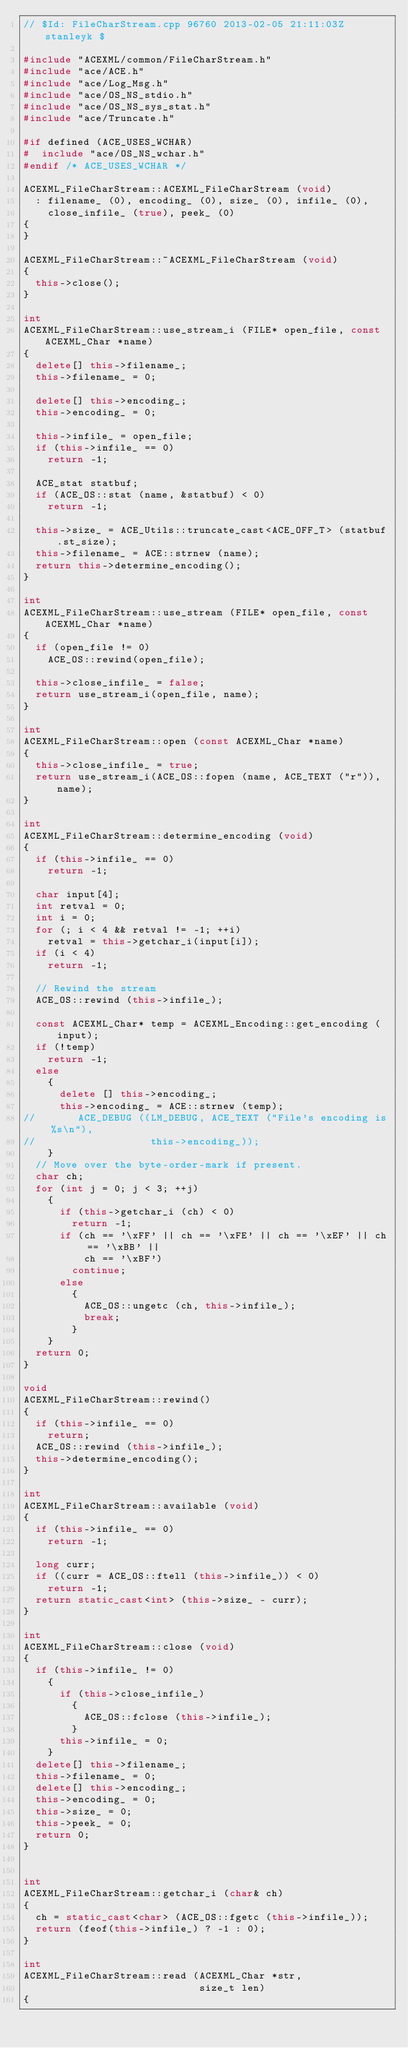Convert code to text. <code><loc_0><loc_0><loc_500><loc_500><_C++_>// $Id: FileCharStream.cpp 96760 2013-02-05 21:11:03Z stanleyk $

#include "ACEXML/common/FileCharStream.h"
#include "ace/ACE.h"
#include "ace/Log_Msg.h"
#include "ace/OS_NS_stdio.h"
#include "ace/OS_NS_sys_stat.h"
#include "ace/Truncate.h"

#if defined (ACE_USES_WCHAR)
#  include "ace/OS_NS_wchar.h"
#endif /* ACE_USES_WCHAR */

ACEXML_FileCharStream::ACEXML_FileCharStream (void)
  : filename_ (0), encoding_ (0), size_ (0), infile_ (0),
    close_infile_ (true), peek_ (0)
{
}

ACEXML_FileCharStream::~ACEXML_FileCharStream (void)
{
  this->close();
}

int
ACEXML_FileCharStream::use_stream_i (FILE* open_file, const ACEXML_Char *name)
{
  delete[] this->filename_;
  this->filename_ = 0;

  delete[] this->encoding_;
  this->encoding_ = 0;

  this->infile_ = open_file;
  if (this->infile_ == 0)
    return -1;

  ACE_stat statbuf;
  if (ACE_OS::stat (name, &statbuf) < 0)
    return -1;

  this->size_ = ACE_Utils::truncate_cast<ACE_OFF_T> (statbuf.st_size);
  this->filename_ = ACE::strnew (name);
  return this->determine_encoding();
}

int
ACEXML_FileCharStream::use_stream (FILE* open_file, const ACEXML_Char *name)
{
  if (open_file != 0)
    ACE_OS::rewind(open_file);

  this->close_infile_ = false;
  return use_stream_i(open_file, name);
}

int
ACEXML_FileCharStream::open (const ACEXML_Char *name)
{
  this->close_infile_ = true;
  return use_stream_i(ACE_OS::fopen (name, ACE_TEXT ("r")), name);
}

int
ACEXML_FileCharStream::determine_encoding (void)
{
  if (this->infile_ == 0)
    return -1;

  char input[4];
  int retval = 0;
  int i = 0;
  for (; i < 4 && retval != -1; ++i)
    retval = this->getchar_i(input[i]);
  if (i < 4)
    return -1;

  // Rewind the stream
  ACE_OS::rewind (this->infile_);

  const ACEXML_Char* temp = ACEXML_Encoding::get_encoding (input);
  if (!temp)
    return -1;
  else
    {
      delete [] this->encoding_;
      this->encoding_ = ACE::strnew (temp);
//       ACE_DEBUG ((LM_DEBUG, ACE_TEXT ("File's encoding is %s\n"),
//                   this->encoding_));
    }
  // Move over the byte-order-mark if present.
  char ch;
  for (int j = 0; j < 3; ++j)
    {
      if (this->getchar_i (ch) < 0)
        return -1;
      if (ch == '\xFF' || ch == '\xFE' || ch == '\xEF' || ch == '\xBB' ||
          ch == '\xBF')
        continue;
      else
        {
          ACE_OS::ungetc (ch, this->infile_);
          break;
        }
    }
  return 0;
}

void
ACEXML_FileCharStream::rewind()
{
  if (this->infile_ == 0)
    return;
  ACE_OS::rewind (this->infile_);
  this->determine_encoding();
}

int
ACEXML_FileCharStream::available (void)
{
  if (this->infile_ == 0)
    return -1;

  long curr;
  if ((curr = ACE_OS::ftell (this->infile_)) < 0)
    return -1;
  return static_cast<int> (this->size_ - curr);
}

int
ACEXML_FileCharStream::close (void)
{
  if (this->infile_ != 0)
    {
      if (this->close_infile_)
        {
          ACE_OS::fclose (this->infile_);
        }
      this->infile_ = 0;
    }
  delete[] this->filename_;
  this->filename_ = 0;
  delete[] this->encoding_;
  this->encoding_ = 0;
  this->size_ = 0;
  this->peek_ = 0;
  return 0;
}


int
ACEXML_FileCharStream::getchar_i (char& ch)
{
  ch = static_cast<char> (ACE_OS::fgetc (this->infile_));
  return (feof(this->infile_) ? -1 : 0);
}

int
ACEXML_FileCharStream::read (ACEXML_Char *str,
                             size_t len)
{</code> 